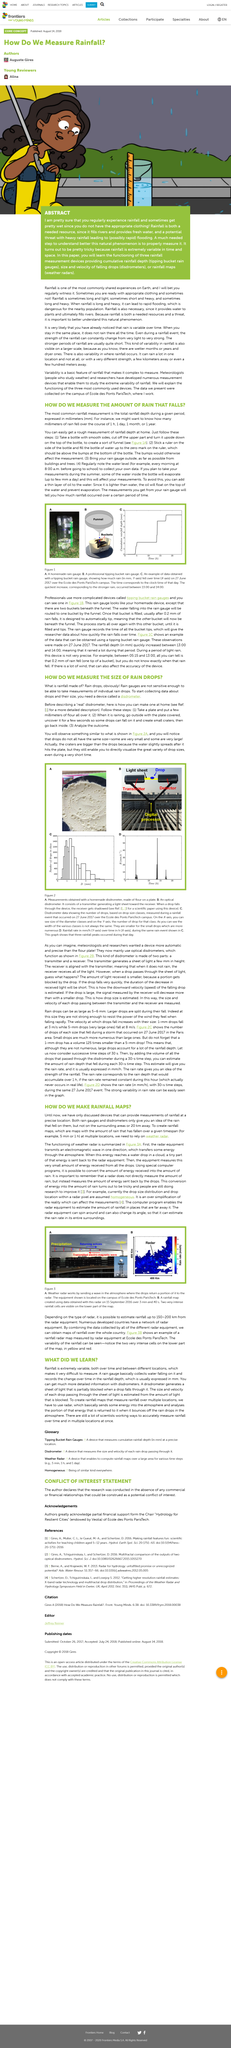Mention a couple of crucial points in this snapshot. Rain gauges and disdrometers are devices that provide an estimation of the rainfall that fell on them, but not on the surrounding areas, as they are only able to measure the rainfall directly above them. The title of the article is "How do we measure the size of raindrops? The most commonly measured form of rainfall is the total rainfall depth during a given period, typically expressed in millimeters (mm). Raining droplets comprise rainfall, which is formed from condensation of water vapor in the atmosphere. To prevent evaporation of collected water, a thin layer of oil should be added to the surface. 